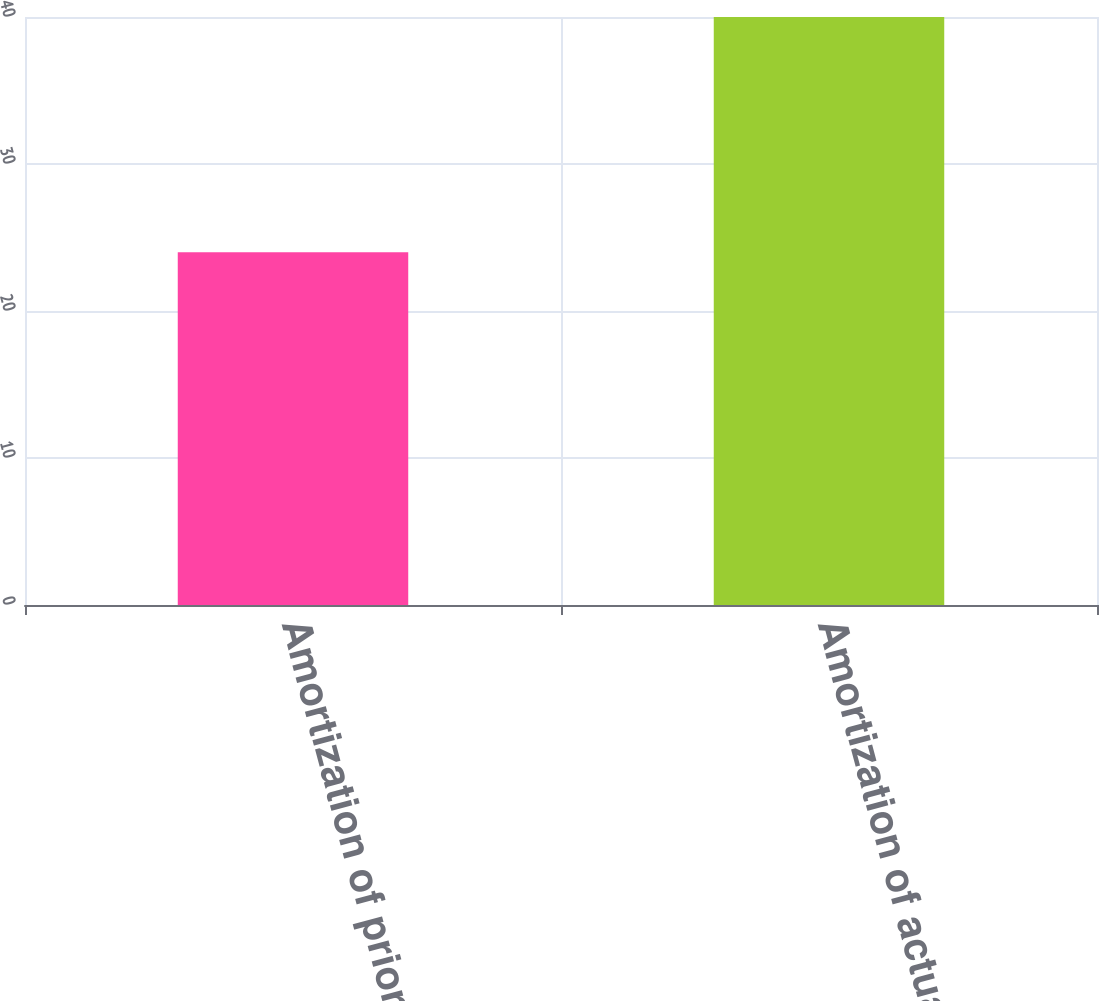Convert chart. <chart><loc_0><loc_0><loc_500><loc_500><bar_chart><fcel>Amortization of prior service<fcel>Amortization of actuarial<nl><fcel>24<fcel>40<nl></chart> 